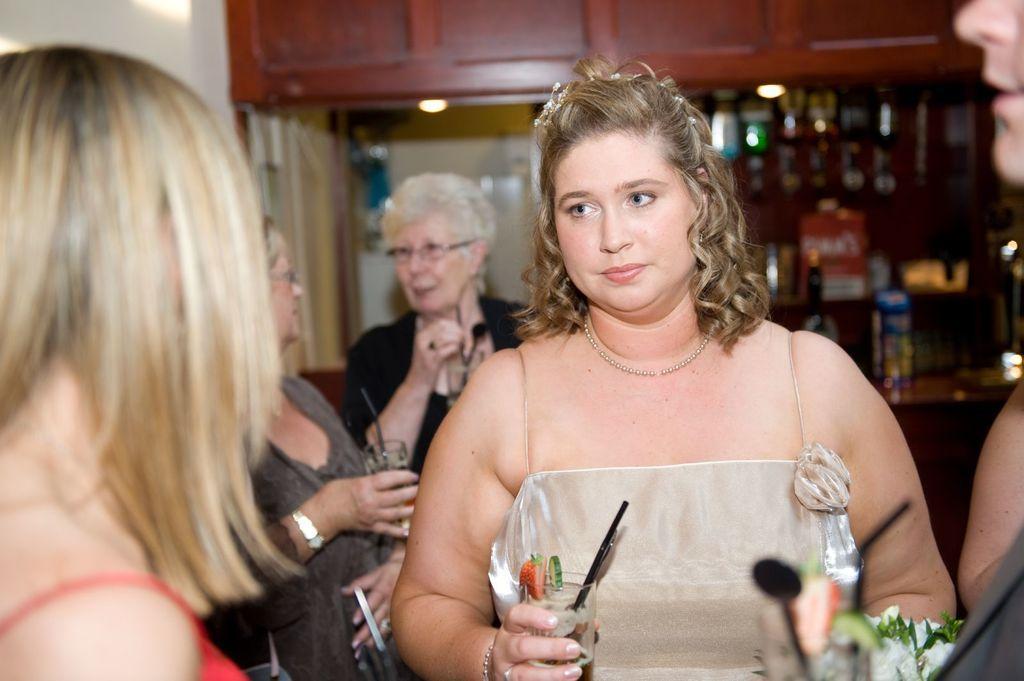Could you give a brief overview of what you see in this image? This picture is clicked inside. In the foreground we can see the group of persons holding the glasses of drinks and standing. On the left corner there is a person. In the background we can see the wooden cabinets, lights and many other objects. 